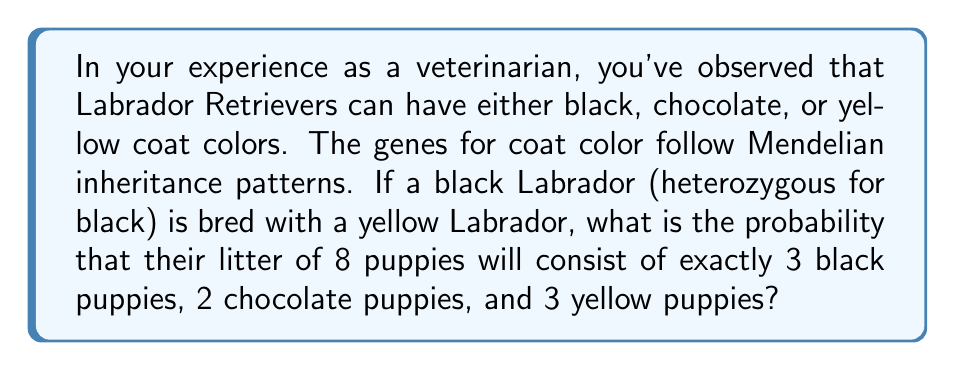Can you solve this math problem? Let's approach this step-by-step:

1) First, we need to understand the genetic probabilities for each coat color in this cross:
   - Black (heterozygous): $B_b$ (where $B$ is dominant black, $b$ is recessive)
   - Yellow: $bb$

2) The possible genotype combinations and their probabilities are:
   $B_b \times bb \rightarrow \frac{1}{2}B_b$ (Black), $\frac{1}{2}bb$ (Yellow)

3) The probability of a chocolate puppy is 0 in this cross, as neither parent carries the chocolate gene.

4) We can model this scenario using a multinomial distribution:
   $$P(X_1=k_1, X_2=k_2, ..., X_m=k_m) = \frac{n!}{k_1!k_2!...k_m!}p_1^{k_1}p_2^{k_2}...p_m^{k_m}$$

   Where:
   $n$ = total number of puppies (8)
   $k_1$ = number of black puppies (3)
   $k_2$ = number of chocolate puppies (2)
   $k_3$ = number of yellow puppies (3)
   $p_1$ = probability of black (1/2)
   $p_2$ = probability of chocolate (0)
   $p_3$ = probability of yellow (1/2)

5) Substituting these values:
   $$P(X_1=3, X_2=2, X_3=3) = \frac{8!}{3!2!3!}(\frac{1}{2})^3(0)^2(\frac{1}{2})^3$$

6) Since $(0)^2 = 0$, the probability of this exact combination is 0.
Answer: 0 